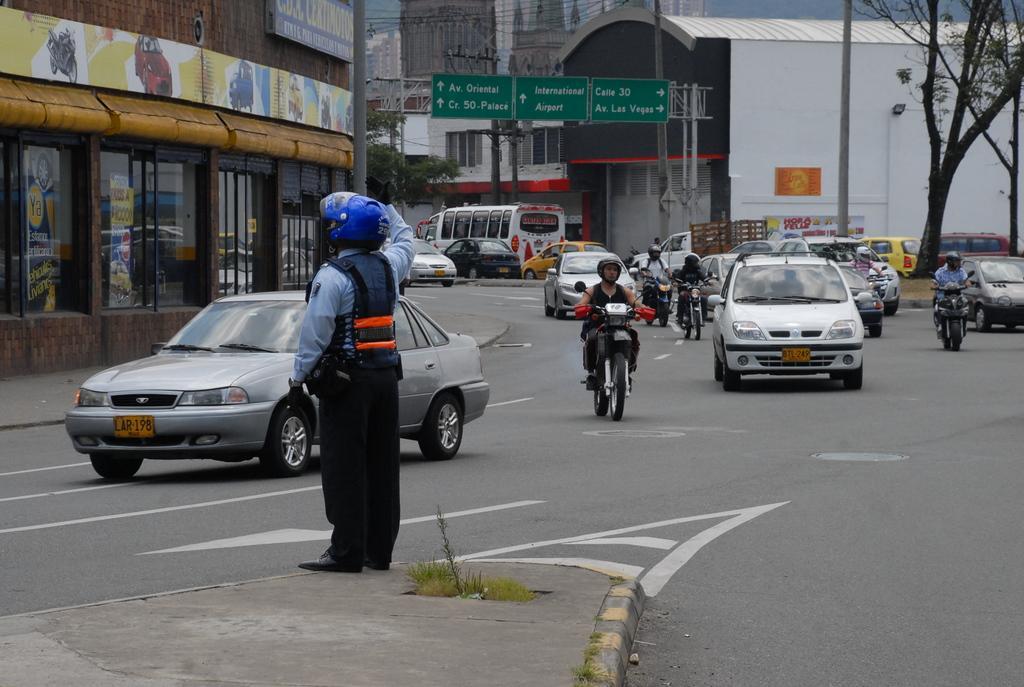Can you describe this image briefly? This is the picture of a place where we have some bikes, cars, vehicles and a person to the side and also we can see some buildings, trees, poles which has some boards and some other things around. 